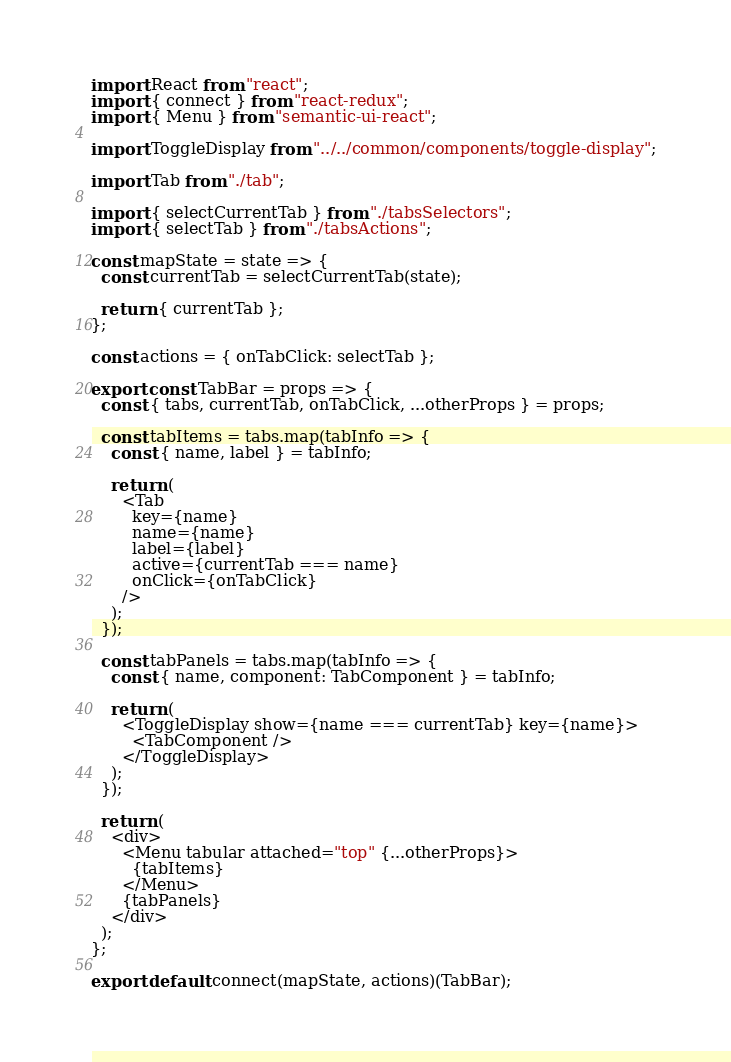<code> <loc_0><loc_0><loc_500><loc_500><_JavaScript_>import React from "react";
import { connect } from "react-redux";
import { Menu } from "semantic-ui-react";

import ToggleDisplay from "../../common/components/toggle-display";

import Tab from "./tab";

import { selectCurrentTab } from "./tabsSelectors";
import { selectTab } from "./tabsActions";

const mapState = state => {
  const currentTab = selectCurrentTab(state);

  return { currentTab };
};

const actions = { onTabClick: selectTab };

export const TabBar = props => {
  const { tabs, currentTab, onTabClick, ...otherProps } = props;

  const tabItems = tabs.map(tabInfo => {
    const { name, label } = tabInfo;

    return (
      <Tab
        key={name}
        name={name}
        label={label}
        active={currentTab === name}
        onClick={onTabClick}
      />
    );
  });

  const tabPanels = tabs.map(tabInfo => {
    const { name, component: TabComponent } = tabInfo;

    return (
      <ToggleDisplay show={name === currentTab} key={name}>
        <TabComponent />
      </ToggleDisplay>
    );
  });

  return (
    <div>
      <Menu tabular attached="top" {...otherProps}>
        {tabItems}
      </Menu>
      {tabPanels}
    </div>
  );
};

export default connect(mapState, actions)(TabBar);
</code> 